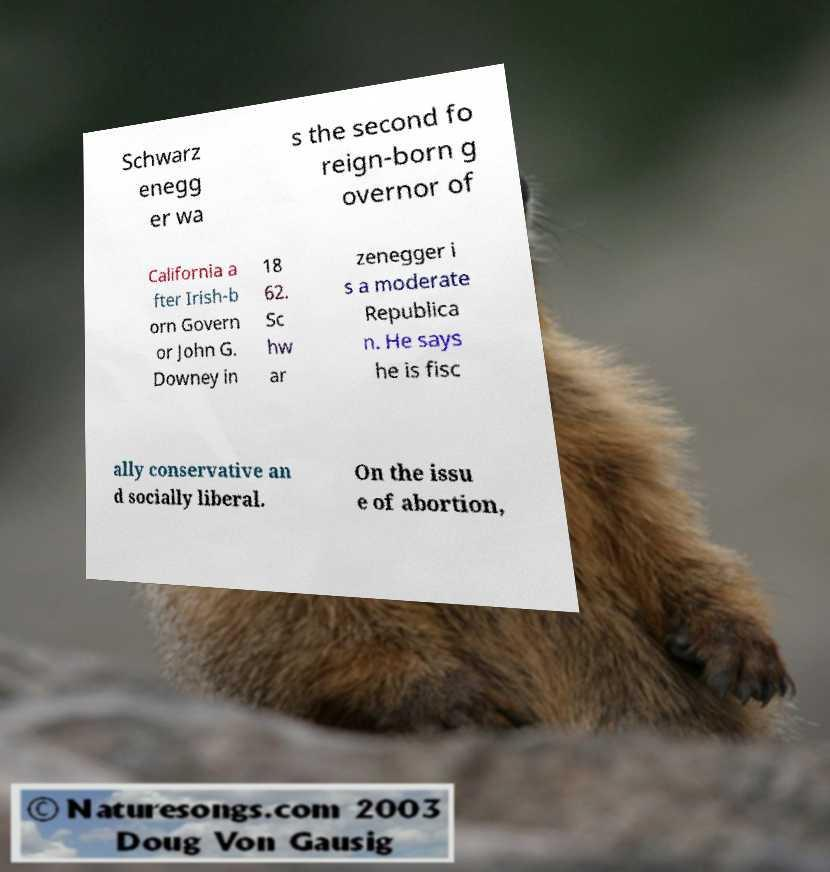Could you extract and type out the text from this image? Schwarz enegg er wa s the second fo reign-born g overnor of California a fter Irish-b orn Govern or John G. Downey in 18 62. Sc hw ar zenegger i s a moderate Republica n. He says he is fisc ally conservative an d socially liberal. On the issu e of abortion, 